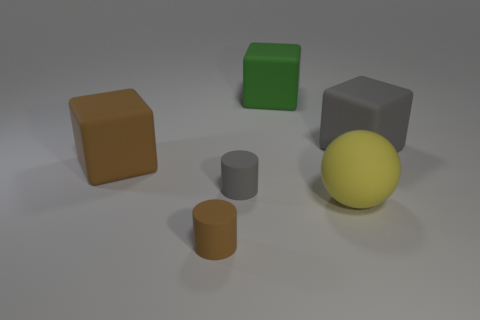Is there a sense of depth or perspective in this composition, and how does it contribute to the overall feel of the image? Yes, the arrangement of objects creates a sense of depth. The largest objects are placed at varying distances from the viewpoint, with smaller objects in between, giving a sense of three-dimensional space. The shadows cast by the objects also contribute to the perspective, enhancing the realism of the scene. 